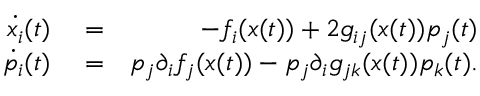Convert formula to latex. <formula><loc_0><loc_0><loc_500><loc_500>\begin{array} { r l r } { \dot { x _ { i } } ( t ) } & = } & { - f _ { i } ( x ( t ) ) + 2 g _ { i j } ( x ( t ) ) p _ { j } ( t ) } \\ { \dot { p _ { i } } ( t ) } & = } & { p _ { j } \partial _ { i } f _ { j } ( x ( t ) ) - p _ { j } \partial _ { i } g _ { j k } ( x ( t ) ) p _ { k } ( t ) . } \end{array}</formula> 